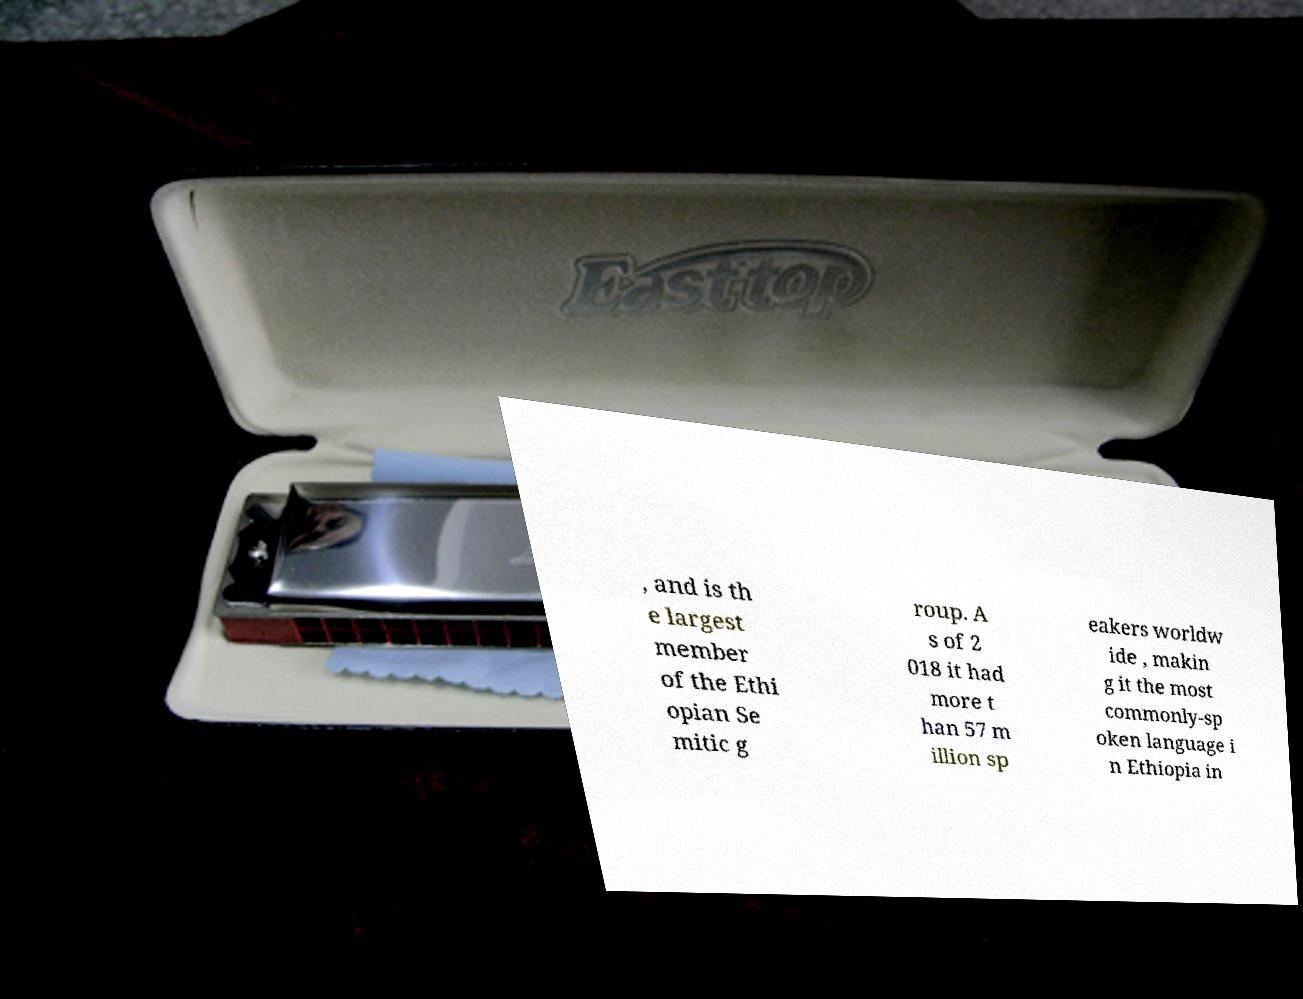Can you read and provide the text displayed in the image?This photo seems to have some interesting text. Can you extract and type it out for me? , and is th e largest member of the Ethi opian Se mitic g roup. A s of 2 018 it had more t han 57 m illion sp eakers worldw ide , makin g it the most commonly-sp oken language i n Ethiopia in 